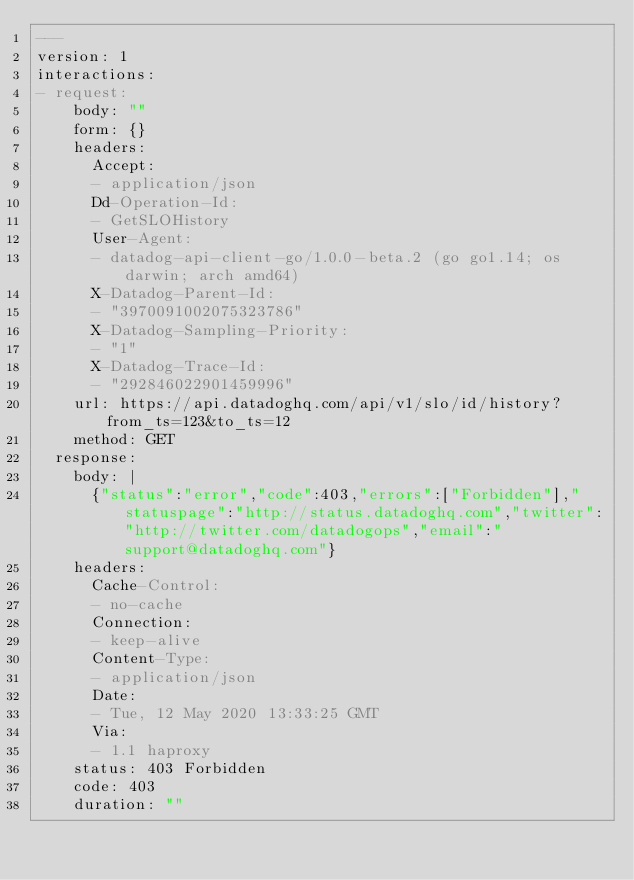Convert code to text. <code><loc_0><loc_0><loc_500><loc_500><_YAML_>---
version: 1
interactions:
- request:
    body: ""
    form: {}
    headers:
      Accept:
      - application/json
      Dd-Operation-Id:
      - GetSLOHistory
      User-Agent:
      - datadog-api-client-go/1.0.0-beta.2 (go go1.14; os darwin; arch amd64)
      X-Datadog-Parent-Id:
      - "3970091002075323786"
      X-Datadog-Sampling-Priority:
      - "1"
      X-Datadog-Trace-Id:
      - "292846022901459996"
    url: https://api.datadoghq.com/api/v1/slo/id/history?from_ts=123&to_ts=12
    method: GET
  response:
    body: |
      {"status":"error","code":403,"errors":["Forbidden"],"statuspage":"http://status.datadoghq.com","twitter":"http://twitter.com/datadogops","email":"support@datadoghq.com"}
    headers:
      Cache-Control:
      - no-cache
      Connection:
      - keep-alive
      Content-Type:
      - application/json
      Date:
      - Tue, 12 May 2020 13:33:25 GMT
      Via:
      - 1.1 haproxy
    status: 403 Forbidden
    code: 403
    duration: ""
</code> 